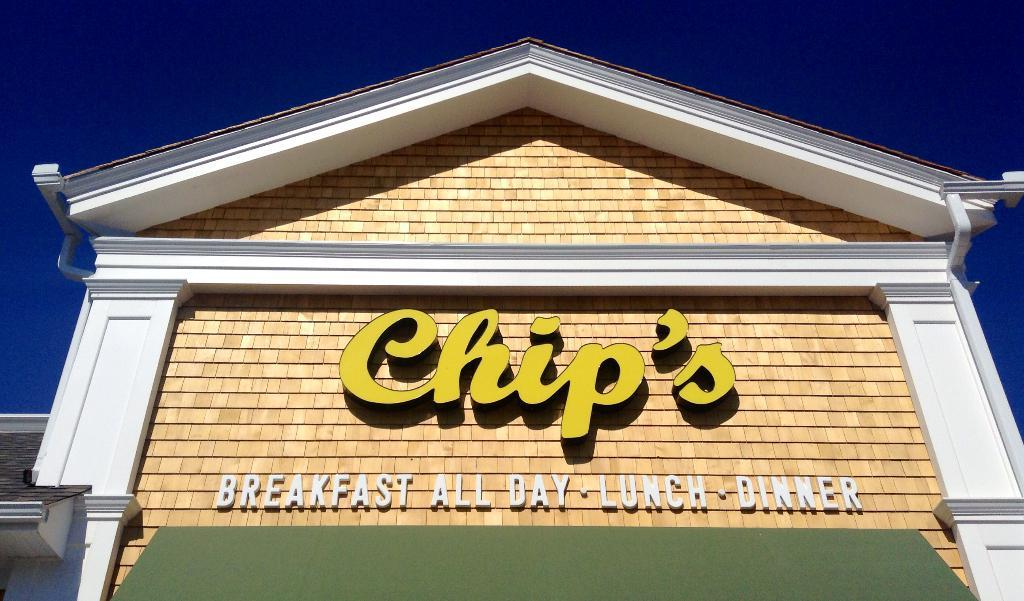What is the main structure in the center of the image? There is a building in the center of the image. What are the basic components of the building? The building has a roof and walls. Is there any signage on the building? Yes, there is a naming board on the building. What can be seen at the top of the image? The sky is visible at the top of the image. What type of ice can be seen melting on the ground in the image? There is no ice or ground present in the image; it features a building with a roof and walls, a naming board, and a visible sky. 